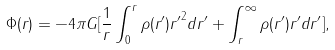Convert formula to latex. <formula><loc_0><loc_0><loc_500><loc_500>\Phi ( r ) = - 4 \pi G [ \frac { 1 } { r } \int _ { 0 } ^ { r } \rho ( r ^ { \prime } ) { r ^ { \prime } } ^ { 2 } d r ^ { \prime } + \int _ { r } ^ { \infty } \rho ( r ^ { \prime } ) r ^ { \prime } d r ^ { \prime } ] ,</formula> 